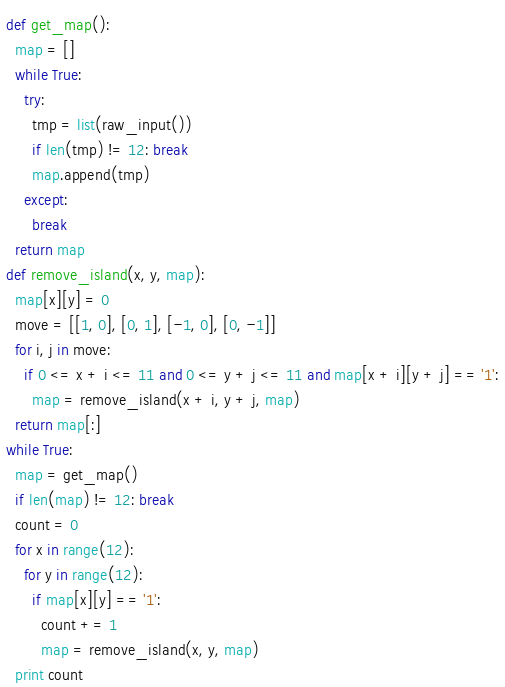Convert code to text. <code><loc_0><loc_0><loc_500><loc_500><_Python_>def get_map():
  map = []
  while True:
    try:
      tmp = list(raw_input())
      if len(tmp) != 12: break
      map.append(tmp)
    except:
      break
  return map
def remove_island(x, y, map):
  map[x][y] = 0
  move = [[1, 0], [0, 1], [-1, 0], [0, -1]]
  for i, j in move:
    if 0 <= x + i <= 11 and 0 <= y + j <= 11 and map[x + i][y + j] == '1':
      map = remove_island(x + i, y + j, map)
  return map[:]
while True:
  map = get_map()
  if len(map) != 12: break
  count = 0
  for x in range(12):
    for y in range(12):
      if map[x][y] == '1':
        count += 1
        map = remove_island(x, y, map)
  print count
</code> 